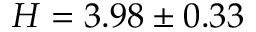Convert formula to latex. <formula><loc_0><loc_0><loc_500><loc_500>H = 3 . 9 8 \pm 0 . 3 3</formula> 